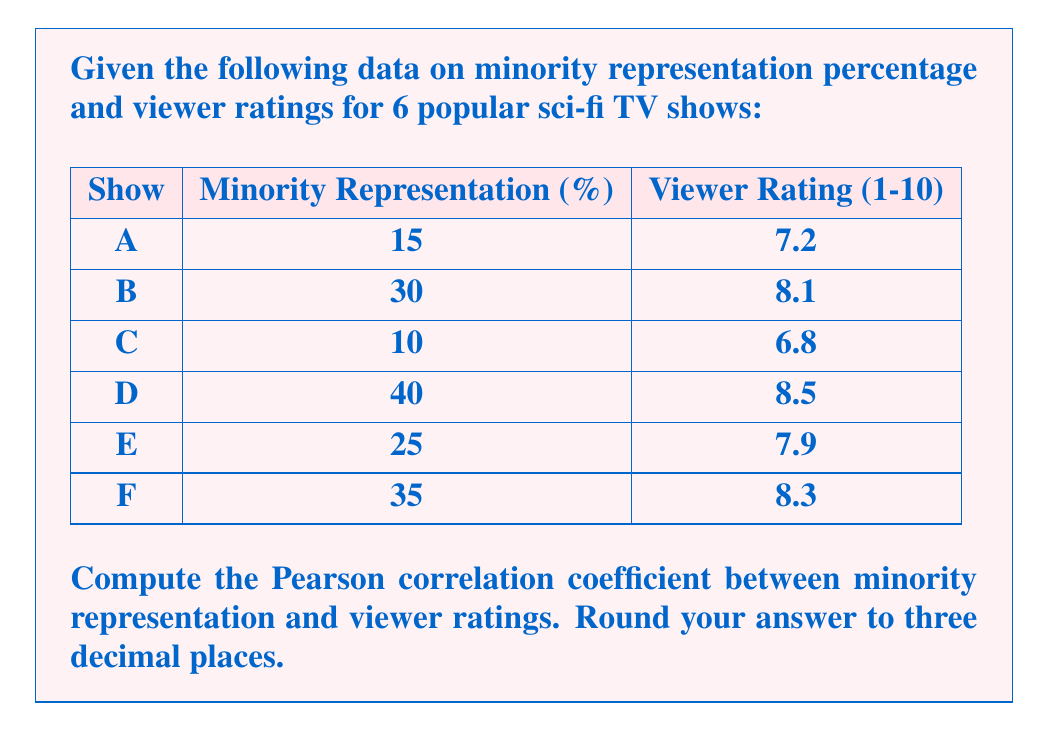Show me your answer to this math problem. To calculate the Pearson correlation coefficient, we'll follow these steps:

1. Calculate the means of X (minority representation) and Y (viewer ratings):
   $\bar{X} = \frac{15 + 30 + 10 + 40 + 25 + 35}{6} = 25.83$
   $\bar{Y} = \frac{7.2 + 8.1 + 6.8 + 8.5 + 7.9 + 8.3}{6} = 7.80$

2. Calculate the deviations from the mean for each variable:
   X deviations: -10.83, 4.17, -15.83, 14.17, -0.83, 9.17
   Y deviations: -0.60, 0.30, -1.00, 0.70, 0.10, 0.50

3. Calculate the product of the deviations:
   6.50, 1.25, 15.83, 9.92, -0.08, 4.58

4. Sum the products of deviations:
   $\sum (X - \bar{X})(Y - \bar{Y}) = 38.00$

5. Calculate the sum of squared deviations for each variable:
   $\sum (X - \bar{X})^2 = 677.83$
   $\sum (Y - \bar{Y})^2 = 2.35$

6. Apply the correlation coefficient formula:

   $$r = \frac{\sum (X - \bar{X})(Y - \bar{Y})}{\sqrt{\sum (X - \bar{X})^2 \sum (Y - \bar{Y})^2}}$$

   $$r = \frac{38.00}{\sqrt{677.83 \times 2.35}}$$

   $$r = \frac{38.00}{\sqrt{1592.90}} = \frac{38.00}{39.91} = 0.952$$

7. Round to three decimal places: 0.952
Answer: 0.952 